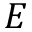Convert formula to latex. <formula><loc_0><loc_0><loc_500><loc_500>E</formula> 